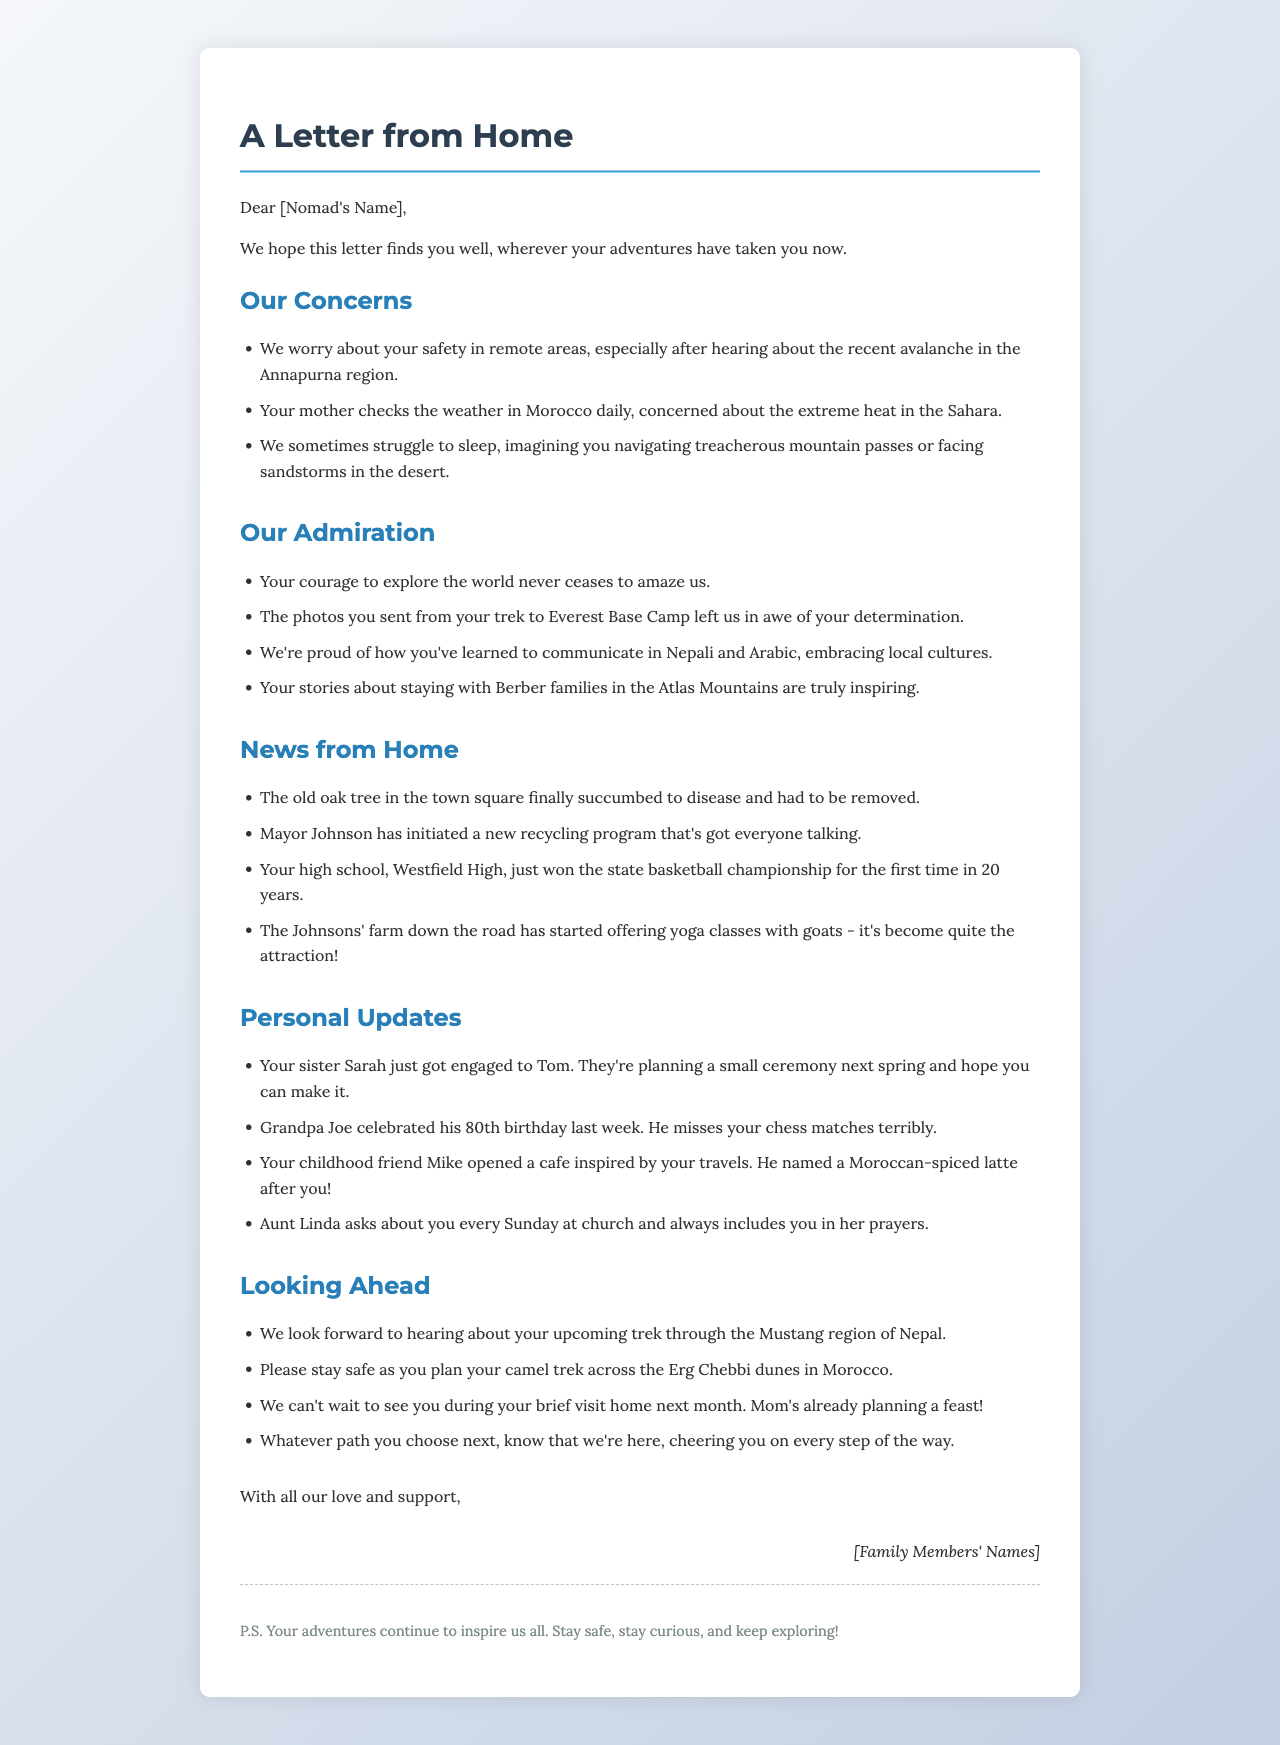What is the greeting of the letter? The greeting is the opening line of the letter directed to the nomad.
Answer: Dear [Nomad's Name], What concern is mentioned about the nomad's safety? One of the family concerns is about safety in remote areas, particularly referencing a recent event.
Answer: recent avalanche in the Annapurna region How many years has it been since the high school won the championship? The document states the specific milestone achieved by Westfield High.
Answer: 20 years Which family member just got engaged? The letter includes a personal update about a family member's engagement.
Answer: Sarah What has the Mayor initiated in the hometown? The letter includes a news update about a local government initiative.
Answer: recycling program What is the signature of the letter? The signature indicates who the letter is from, typically the family members.
Answer: [Family Members' Names] What do the family members look forward to hearing about? The family expresses their anticipation for updates about the nomad's future adventures.
Answer: upcoming trek through the Mustang region of Nepal Which local attraction is mentioned related to yoga? A specific farm activity is mentioned as a new attraction in the neighborhood.
Answer: yoga classes with goats What is included in the postscript? The postscript is a final note that enhances the message of the letter.
Answer: Your adventures continue to inspire us all. Stay safe, stay curious, and keep exploring! 